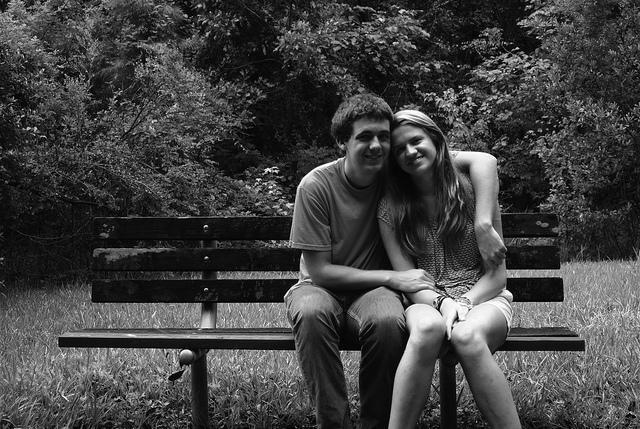How many people are visible?
Give a very brief answer. 2. How many clock faces are in the shade?
Give a very brief answer. 0. 